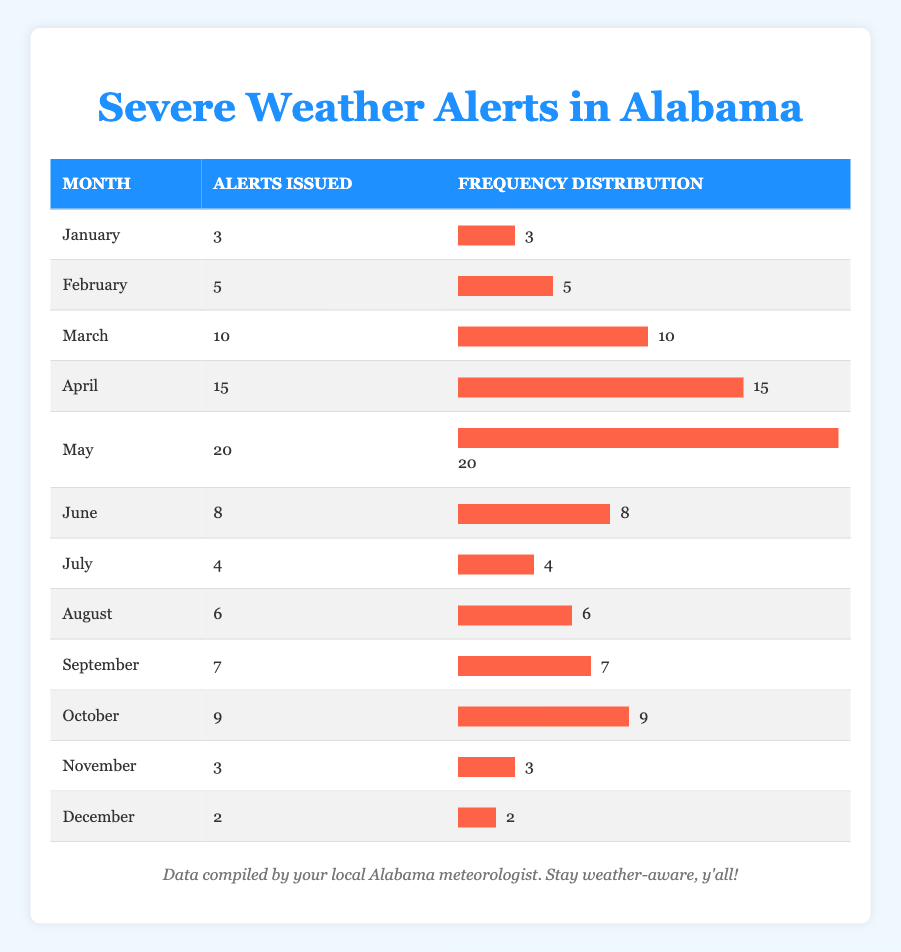What is the month with the highest number of severe weather alerts issued? By looking at the "Alerts Issued" column, May has the highest number with a total of 20 alerts.
Answer: May How many severe weather alerts were issued in October? October has 9 alerts issued according to the table.
Answer: 9 What is the total number of severe weather alerts issued from January to June? Adding the alerts from January (3), February (5), March (10), April (15), May (20), and June (8) gives a total of 3 + 5 + 10 + 15 + 20 + 8 = 61 alerts.
Answer: 61 Which month had fewer alerts issued: November or December? November had 3 alerts while December had 2 alerts. Since 2 is less than 3, December had fewer alerts issued.
Answer: December What is the average number of alerts issued per month over the year? To find the average, sum all alerts (3 + 5 + 10 + 15 + 20 + 8 + 4 + 6 + 7 + 9 + 3 + 2 = 92) and divide by 12 months, so 92/12 = 7.67.
Answer: 7.67 Was there a month in which fewer than 5 alerts were issued? Yes, according to the table, both January (3) and December (2) had fewer than 5 alerts issued.
Answer: Yes What is the difference in the number of alerts issued between May and June? May had 20 alerts and June had 8 alerts. The difference is 20 - 8 = 12 alerts.
Answer: 12 Which months combined had a total of 15 alerts issued? April (15 alerts) alone had 15 alerts, while if looking for combinations, September (7) and July (4) total 11, and thus none directly add to 15. Only April meets the criterion.
Answer: April If we combine the alerts from January and March, how many are there in total? January had 3 alerts and March had 10 alerts, so combined they total 3 + 10 = 13 alerts.
Answer: 13 How many months had more than 10 alerts issued? The months with more than 10 alerts are March (10), April (15), and May (20). Thus, there are 3 months in total.
Answer: 3 